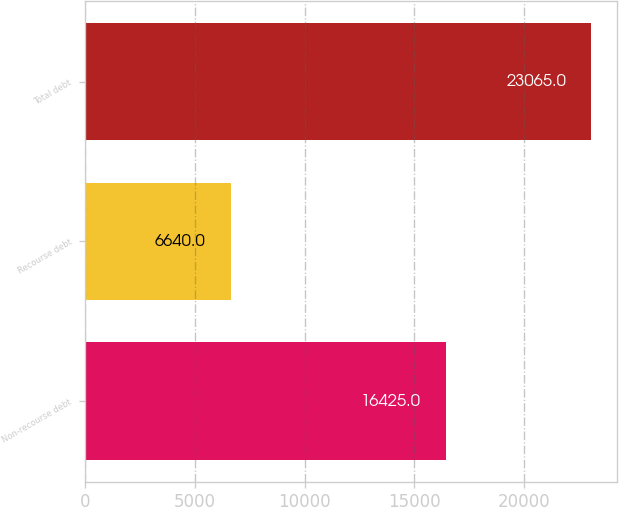<chart> <loc_0><loc_0><loc_500><loc_500><bar_chart><fcel>Non-recourse debt<fcel>Recourse debt<fcel>Total debt<nl><fcel>16425<fcel>6640<fcel>23065<nl></chart> 